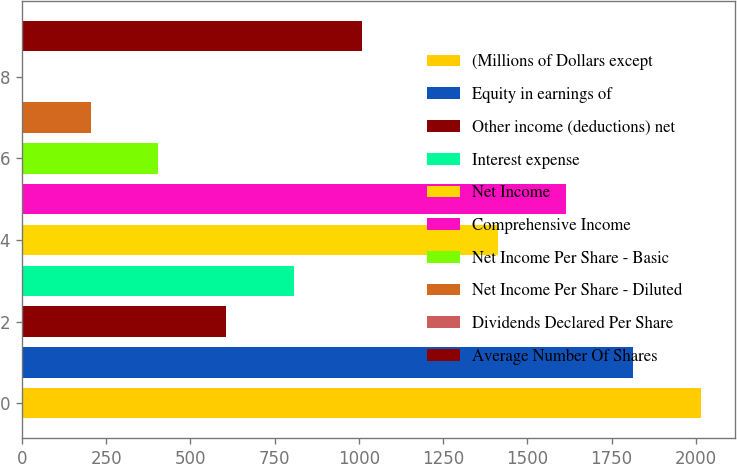<chart> <loc_0><loc_0><loc_500><loc_500><bar_chart><fcel>(Millions of Dollars except<fcel>Equity in earnings of<fcel>Other income (deductions) net<fcel>Interest expense<fcel>Net Income<fcel>Comprehensive Income<fcel>Net Income Per Share - Basic<fcel>Net Income Per Share - Diluted<fcel>Dividends Declared Per Share<fcel>Average Number Of Shares<nl><fcel>2016<fcel>1814.65<fcel>606.67<fcel>808<fcel>1411.99<fcel>1613.32<fcel>405.34<fcel>204.01<fcel>2.68<fcel>1009.33<nl></chart> 